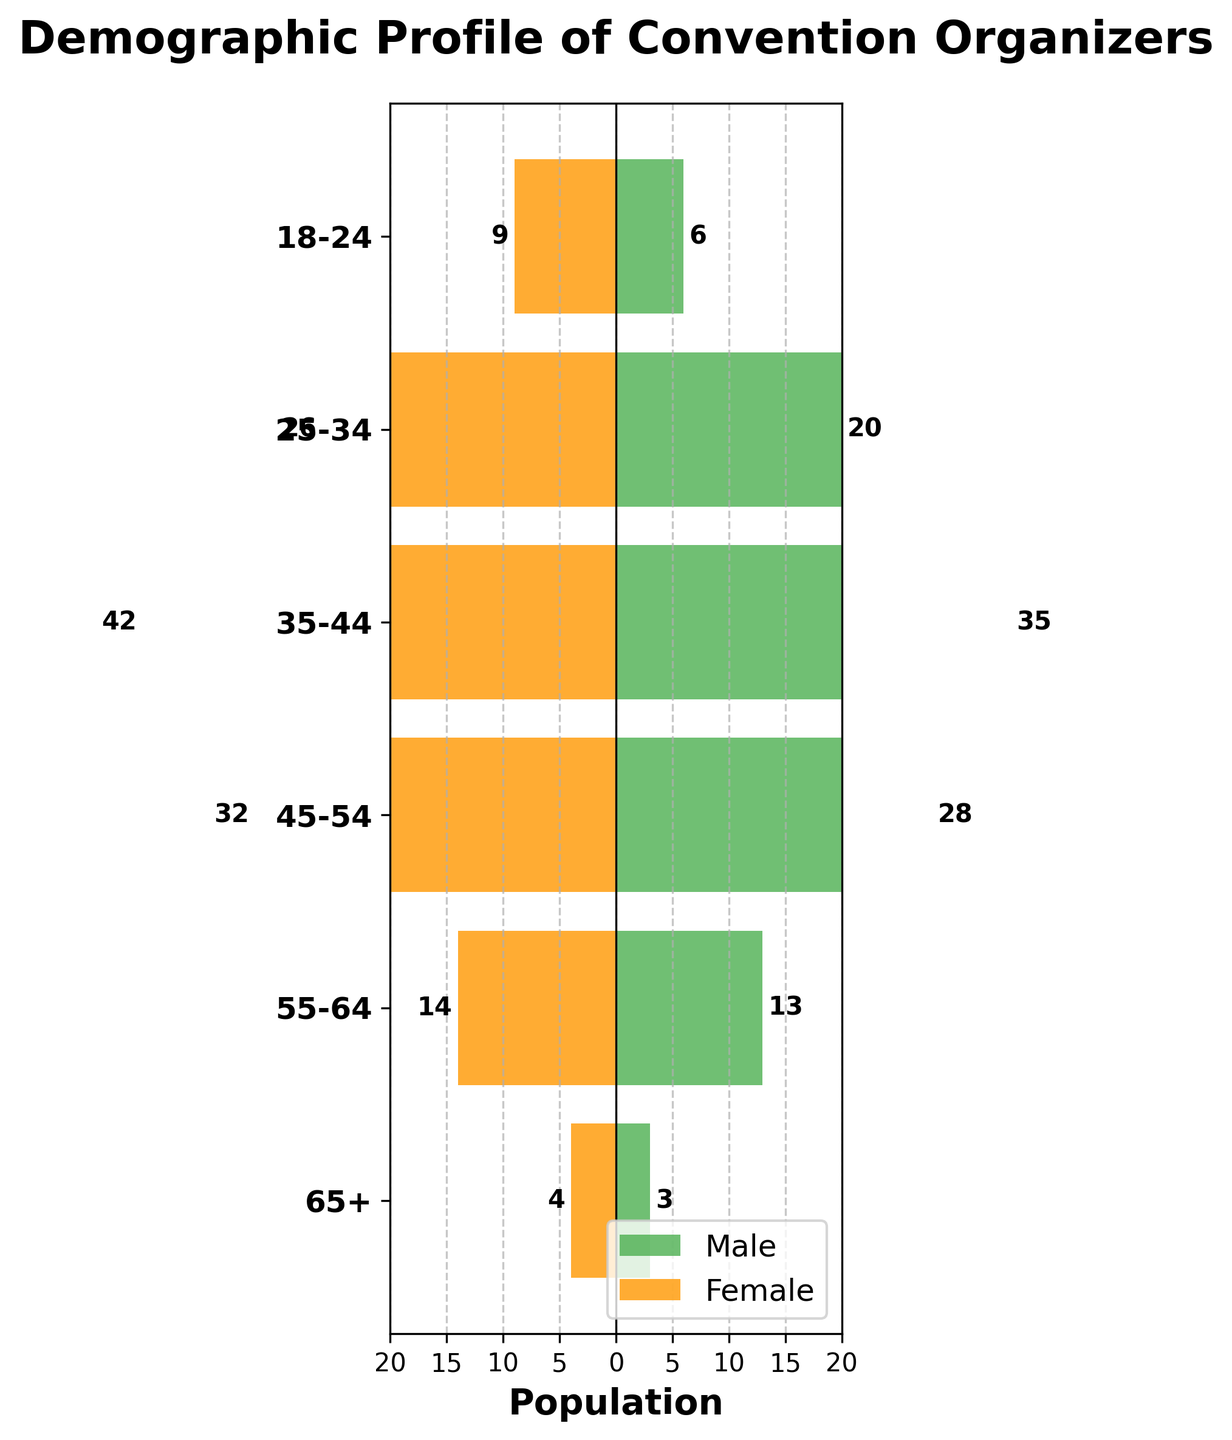What is the title of the figure? The title of the figure is usually located at the top of the chart which helps to understand the main subject being visualized. In this case, the title is "Demographic Profile of Convention Organizers".
Answer: Demographic Profile of Convention Organizers How many age groups are displayed in the figure? By examining the y-axis, one can count the number of unique labels representing age groups. In this figure, there are six age groups displayed.
Answer: 6 Which age group has the highest number of male organizers? By inspecting the length of the green bars representing males, the age group with the longest bar is the one with the highest count. The 35-44 age group has the longest green bar.
Answer: 35-44 What is the total number of male organizers in the 45-54 and 55-64 age groups combined? To find this, sum the number of male organizers in the 45-54 age group (12) and the 55-64 age group (6). This results in 12 + 6 = 18 male organizers.
Answer: 18 Which age group has an equal number of male and female organizers? By comparing the lengths of the green (male) and orange (female) bars for each age group, look for bars of equal length. For the 65+ age group, both bars are of equal length, each at 1.
Answer: 65+ In the 35-44 age group, are there more female or male organizers, and by how much? By comparing the lengths of the bars for the 35-44 age group, the orange bar for females reaches -13 while the green bar for males reaches 11. The difference is 13 - 11 = 2, indicating there are 2 more female organizers.
Answer: Females, by 2 Across all age groups, which gender has a higher total number of organizers? Summing all values for both genders across all age groups: 
Males: 2 + 8 + 15 + 12 + 6 + 1 + 1 + 5 + 9 + 7 + 3 + 1 + 3 + 7 + 11 + 9 + 4 + 1 = 104
Females: -3 - 10 - 18 - 14 - 5 - 1 - 2 - 7 - 11 - 8 - 4 - 1 - 4 - 9 - 13 - 10 - 5 - 2 = -127
Since the absolute value of -127 is greater, there are more female organizers.
Answer: Females What is the difference in the number of female organizers between the 25-34 and 35-44 age groups? The number of female organizers in the 25-34 age group is 10, and in the 35-44 age group is 18. The difference is 18 - 10 = 8 female organizers.
Answer: 8 Are there any age groups with a negative number of female organizers? By visual inspection, negative values are represented by bars extending to the left. All female data points are negative, indicating all values are already negative by convention.
Answer: Yes Which age group has the lowest number of organizers for both genders combined? Calculate the sum of absolute values of male and female organizers in each age group:
- 18-24: 2 + 3 = 5
- 25-34: 8 + 10 = 18
- 35-44: 15 + 18 = 33
- 45-54: 12 + 14 = 26
- 55-64: 6 + 5 = 11
- 65+: 1 + 1 = 2
The lowest combined number is for the 65+ age group.
Answer: 65+ 